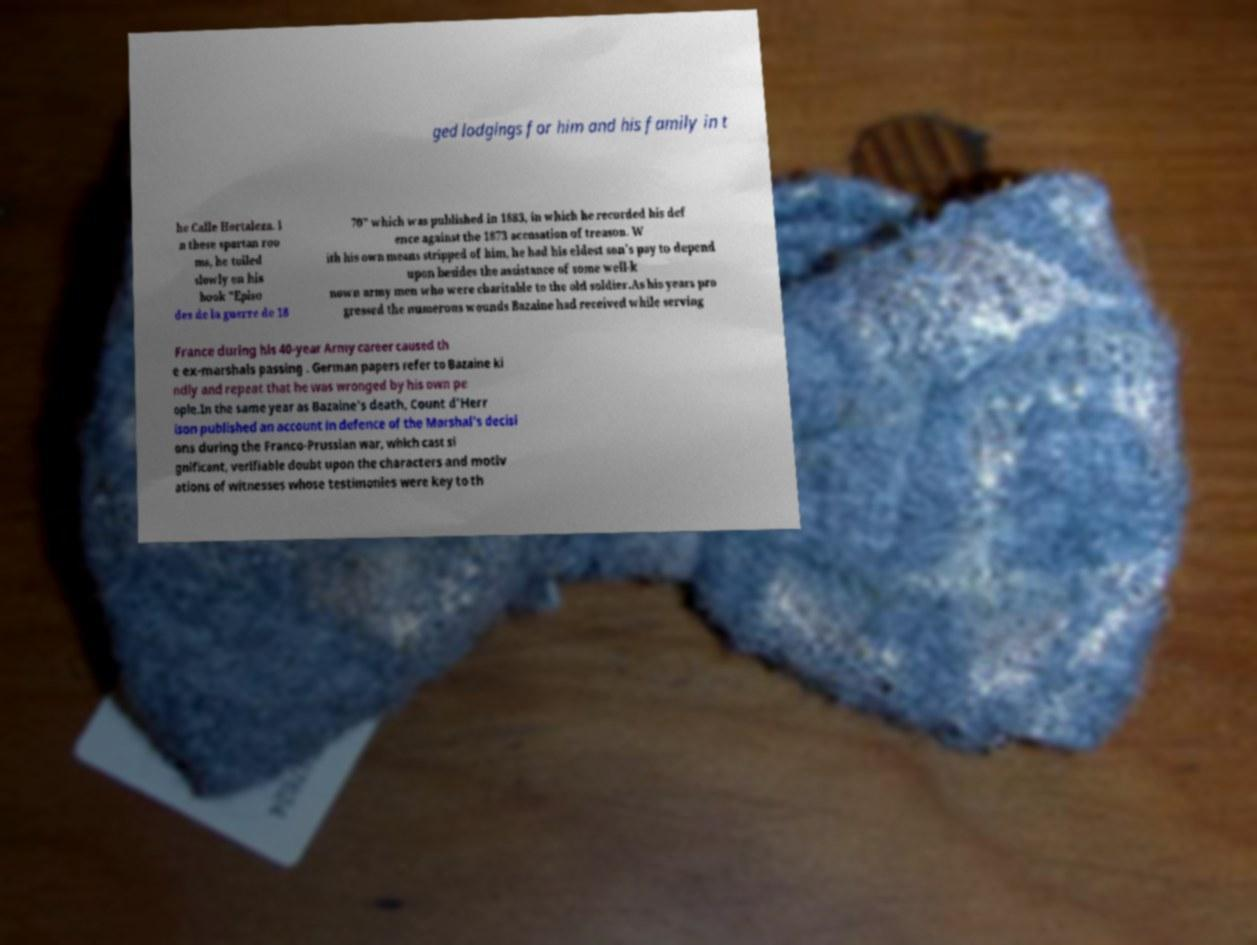Please read and relay the text visible in this image. What does it say? ged lodgings for him and his family in t he Calle Hortaleza. I n these spartan roo ms, he toiled slowly on his book "Episo des de la guerre de 18 70" which was published in 1883, in which he recorded his def ence against the 1873 accusation of treason. W ith his own means stripped of him, he had his eldest son's pay to depend upon besides the assistance of some well-k nown army men who were charitable to the old soldier.As his years pro gressed the numerous wounds Bazaine had received while serving France during his 40-year Army career caused th e ex-marshals passing . German papers refer to Bazaine ki ndly and repeat that he was wronged by his own pe ople.In the same year as Bazaine's death, Count d'Herr ison published an account in defence of the Marshal's decisi ons during the Franco-Prussian war, which cast si gnificant, verifiable doubt upon the characters and motiv ations of witnesses whose testimonies were key to th 